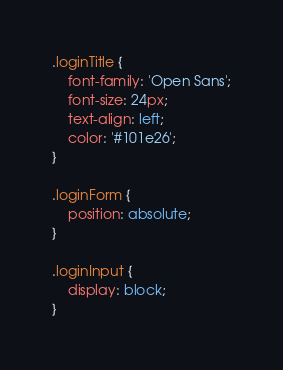<code> <loc_0><loc_0><loc_500><loc_500><_CSS_>.loginTitle {
    font-family: 'Open Sans';
    font-size: 24px;
    text-align: left;
    color: '#101e26';
}

.loginForm {
    position: absolute;
}

.loginInput {
    display: block;
}
</code> 